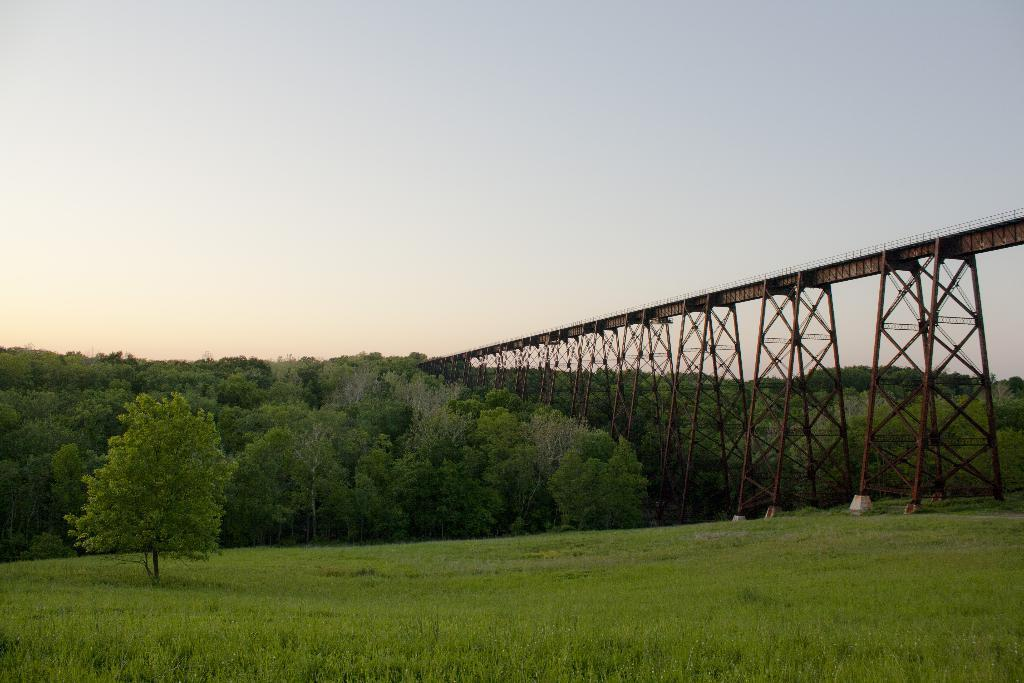What structure can be seen in the right corner of the image? There is a bridge in the right corner of the image. What type of natural elements are visible in the background of the image? There are trees in the background of the image. What is the ground in the image covered with? The ground in the image is covered in greenery. What type of apparel is the bridge wearing in the image? Bridges do not wear apparel, as they are inanimate objects. 